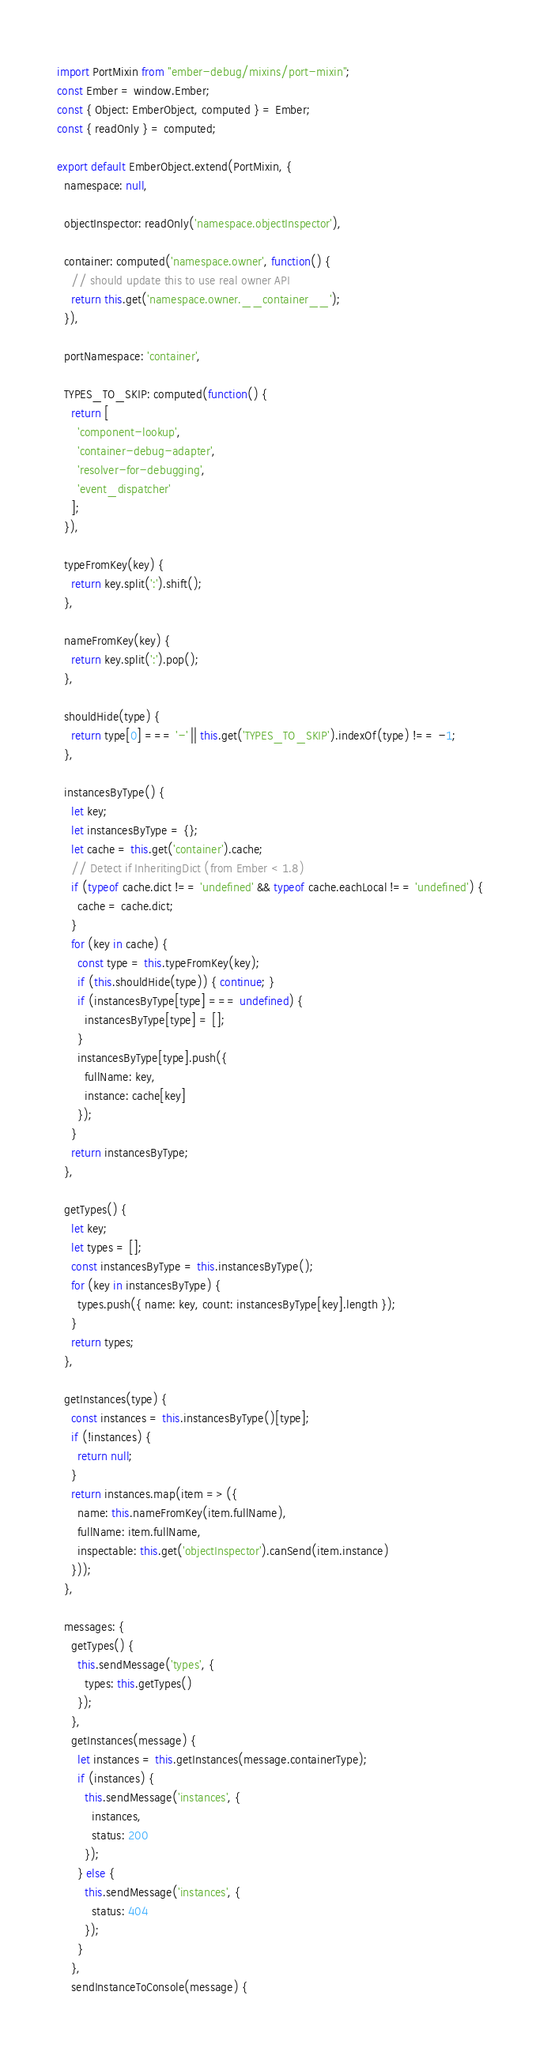Convert code to text. <code><loc_0><loc_0><loc_500><loc_500><_JavaScript_>import PortMixin from "ember-debug/mixins/port-mixin";
const Ember = window.Ember;
const { Object: EmberObject, computed } = Ember;
const { readOnly } = computed;

export default EmberObject.extend(PortMixin, {
  namespace: null,

  objectInspector: readOnly('namespace.objectInspector'),

  container: computed('namespace.owner', function() {
    // should update this to use real owner API
    return this.get('namespace.owner.__container__');
  }),

  portNamespace: 'container',

  TYPES_TO_SKIP: computed(function() {
    return [
      'component-lookup',
      'container-debug-adapter',
      'resolver-for-debugging',
      'event_dispatcher'
    ];
  }),

  typeFromKey(key) {
    return key.split(':').shift();
  },

  nameFromKey(key) {
    return key.split(':').pop();
  },

  shouldHide(type) {
    return type[0] === '-' || this.get('TYPES_TO_SKIP').indexOf(type) !== -1;
  },

  instancesByType() {
    let key;
    let instancesByType = {};
    let cache = this.get('container').cache;
    // Detect if InheritingDict (from Ember < 1.8)
    if (typeof cache.dict !== 'undefined' && typeof cache.eachLocal !== 'undefined') {
      cache = cache.dict;
    }
    for (key in cache) {
      const type = this.typeFromKey(key);
      if (this.shouldHide(type)) { continue; }
      if (instancesByType[type] === undefined) {
        instancesByType[type] = [];
      }
      instancesByType[type].push({
        fullName: key,
        instance: cache[key]
      });
    }
    return instancesByType;
  },

  getTypes() {
    let key;
    let types = [];
    const instancesByType = this.instancesByType();
    for (key in instancesByType) {
      types.push({ name: key, count: instancesByType[key].length });
    }
    return types;
  },

  getInstances(type) {
    const instances = this.instancesByType()[type];
    if (!instances) {
      return null;
    }
    return instances.map(item => ({
      name: this.nameFromKey(item.fullName),
      fullName: item.fullName,
      inspectable: this.get('objectInspector').canSend(item.instance)
    }));
  },

  messages: {
    getTypes() {
      this.sendMessage('types', {
        types: this.getTypes()
      });
    },
    getInstances(message) {
      let instances = this.getInstances(message.containerType);
      if (instances) {
        this.sendMessage('instances', {
          instances,
          status: 200
        });
      } else {
        this.sendMessage('instances', {
          status: 404
        });
      }
    },
    sendInstanceToConsole(message) {</code> 